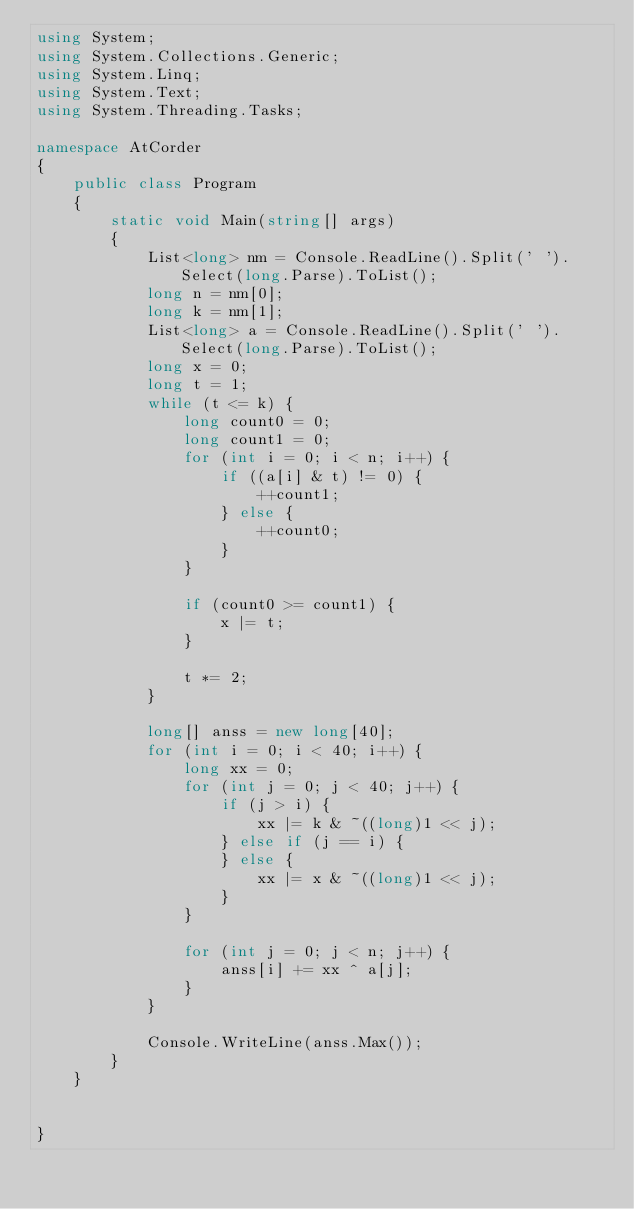<code> <loc_0><loc_0><loc_500><loc_500><_C#_>using System;
using System.Collections.Generic;
using System.Linq;
using System.Text;
using System.Threading.Tasks;

namespace AtCorder
{
	public class Program
	{
		static void Main(string[] args)
		{
			List<long> nm = Console.ReadLine().Split(' ').Select(long.Parse).ToList();
			long n = nm[0];
			long k = nm[1];
			List<long> a = Console.ReadLine().Split(' ').Select(long.Parse).ToList();
			long x = 0;
			long t = 1;
			while (t <= k) {
				long count0 = 0;
				long count1 = 0;
				for (int i = 0; i < n; i++) {
					if ((a[i] & t) != 0) {
						++count1;
					} else {
						++count0;
					}
				}

				if (count0 >= count1) {
					x |= t;
				}

				t *= 2;
			}

			long[] anss = new long[40];
			for (int i = 0; i < 40; i++) {
				long xx = 0;
				for (int j = 0; j < 40; j++) {
					if (j > i) {
						xx |= k & ~((long)1 << j);
					} else if (j == i) {
					} else {
						xx |= x & ~((long)1 << j);
					}
				}

				for (int j = 0; j < n; j++) {
					anss[i] += xx ^ a[j];
				}
			}

			Console.WriteLine(anss.Max());
		}
	}

	
}
</code> 